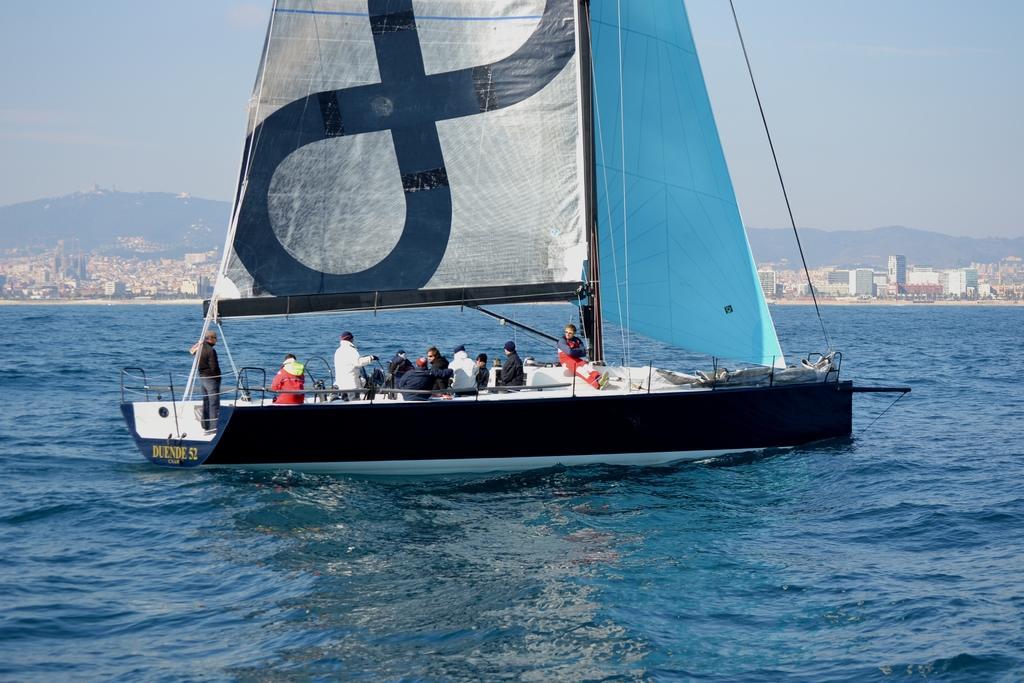How would you summarize this image in a sentence or two? In this image we can see boat. There are people in it. At the bottom of the image there is water. In the background of the image there are mountains, buildings and sky. 